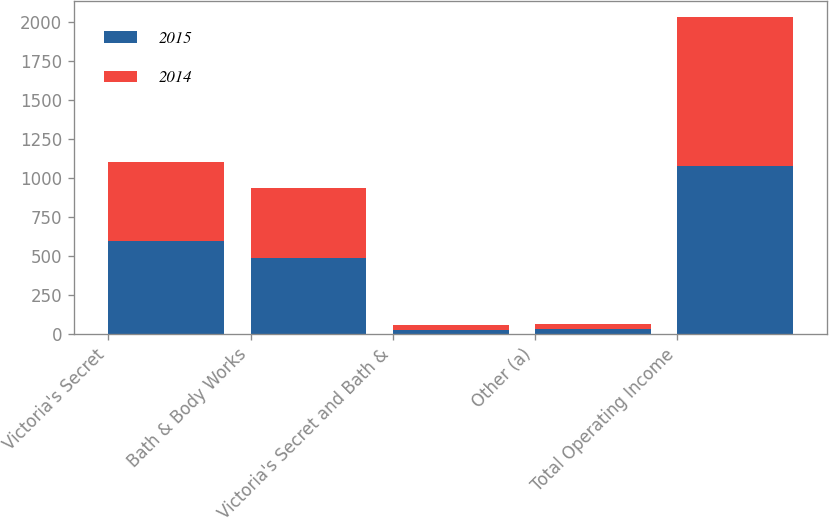Convert chart. <chart><loc_0><loc_0><loc_500><loc_500><stacked_bar_chart><ecel><fcel>Victoria's Secret<fcel>Bath & Body Works<fcel>Victoria's Secret and Bath &<fcel>Other (a)<fcel>Total Operating Income<nl><fcel>2015<fcel>594<fcel>487<fcel>28<fcel>31<fcel>1078<nl><fcel>2014<fcel>509<fcel>449<fcel>29<fcel>30<fcel>957<nl></chart> 